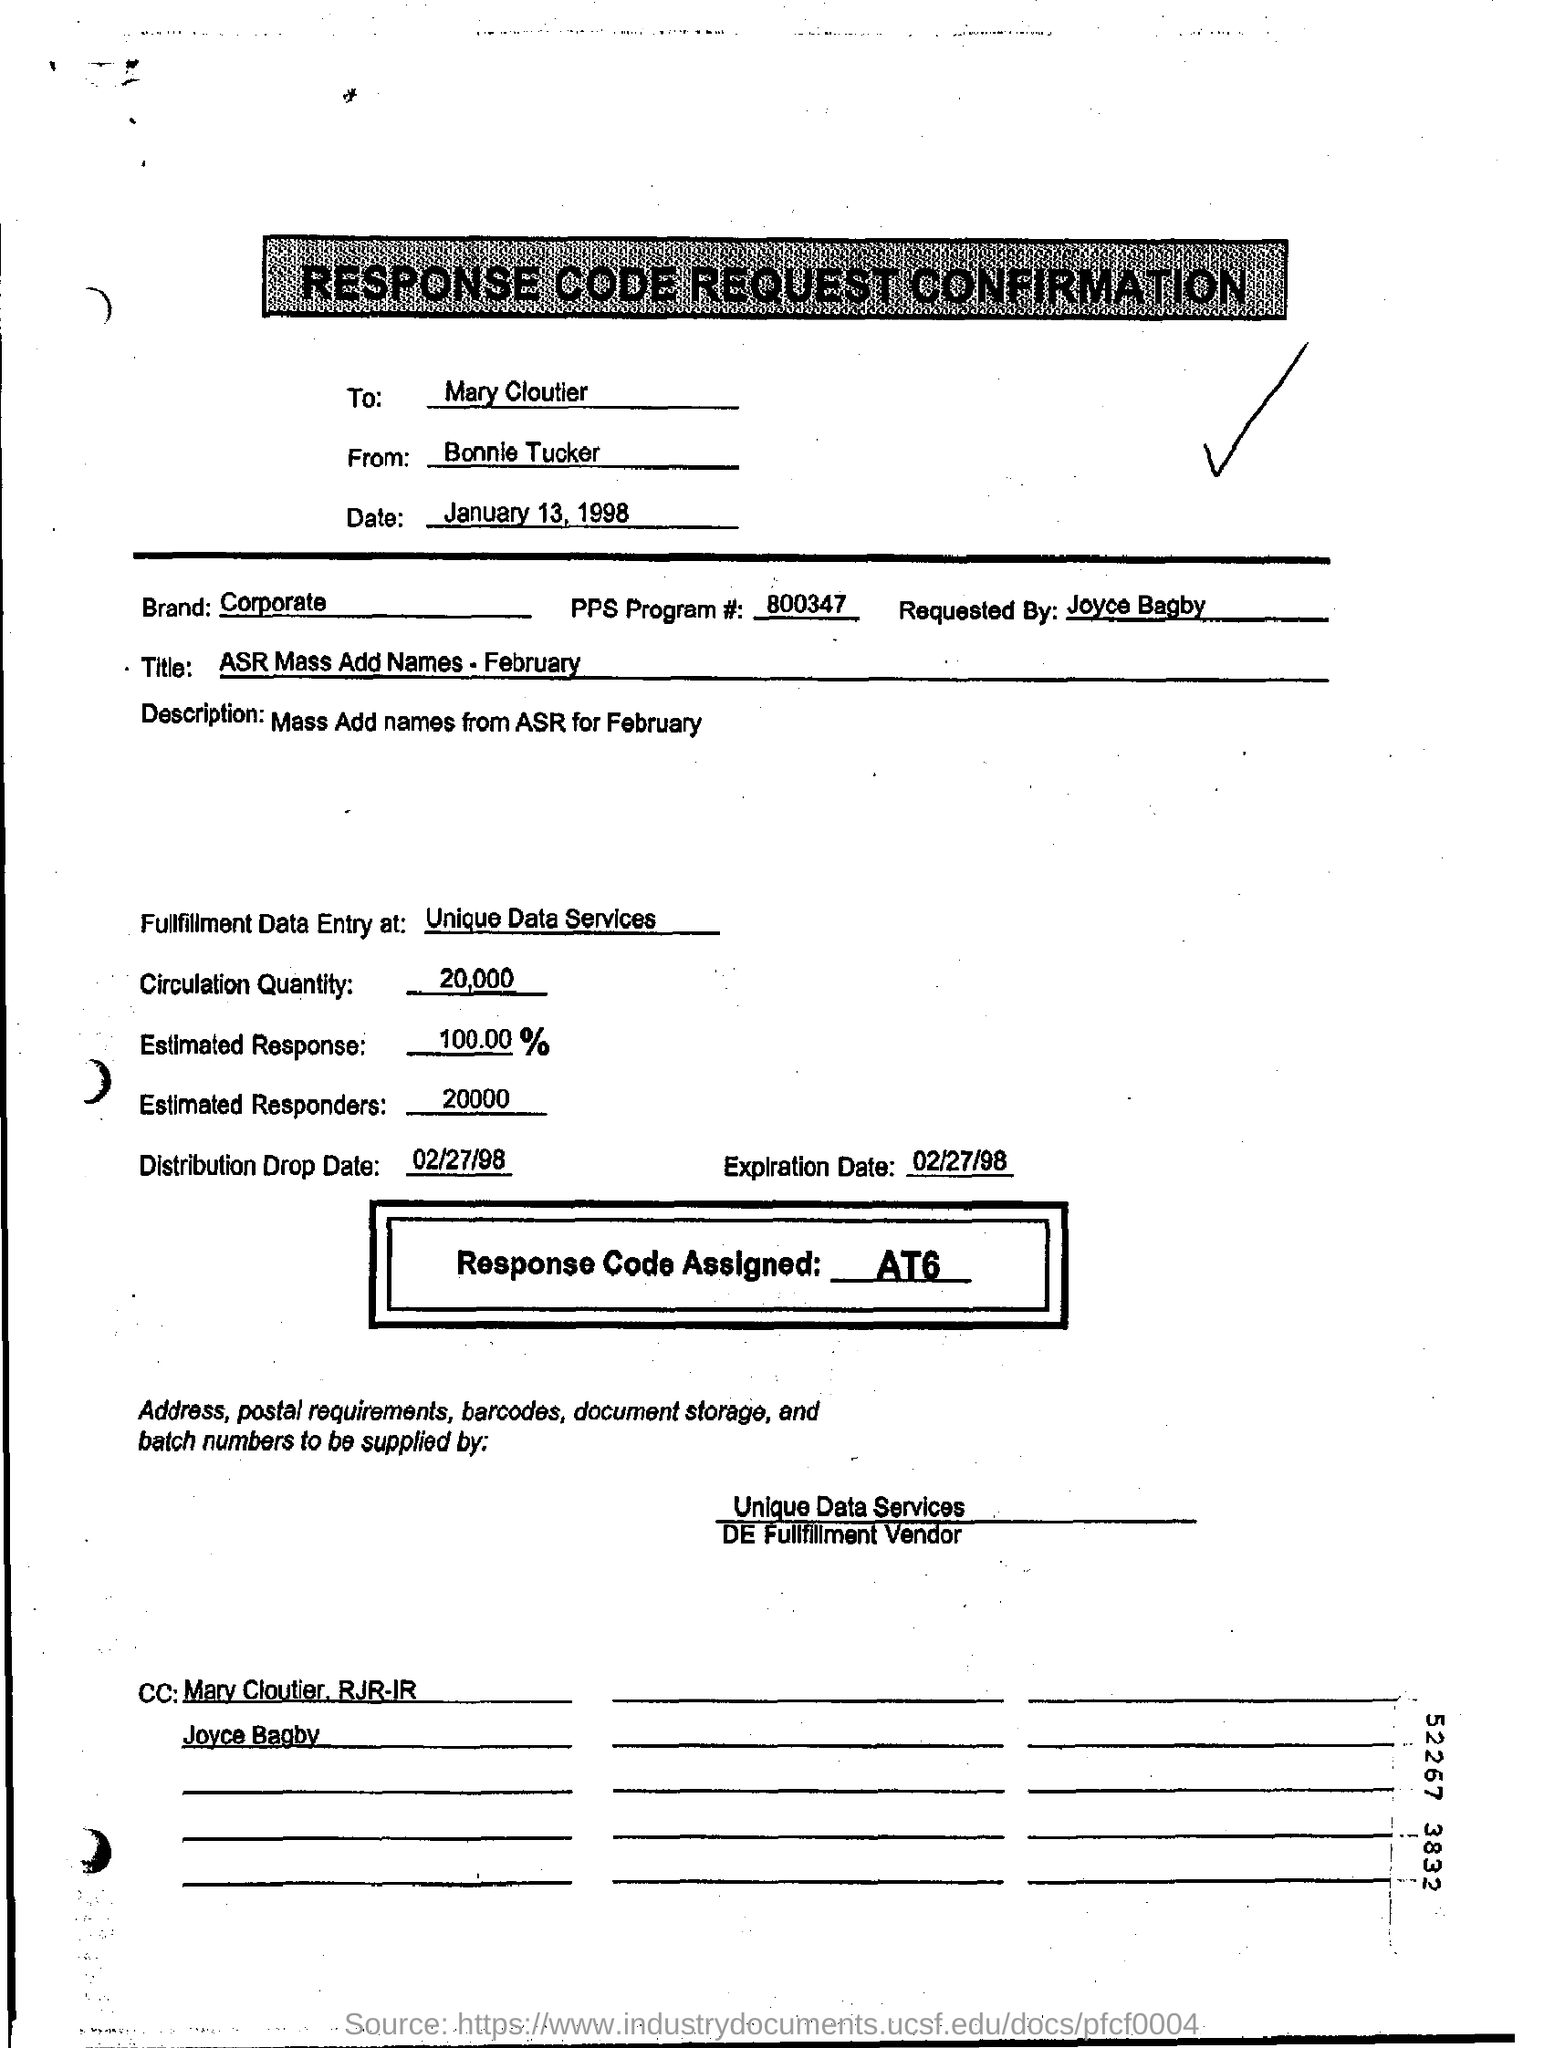List a handful of essential elements in this visual. The circulation quantity is 20,000. What is the response code that has been assigned? The estimated response is 100.00... The person who made the request was Joyce Bagby. The FPS program number is 800347... 